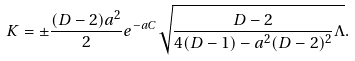Convert formula to latex. <formula><loc_0><loc_0><loc_500><loc_500>K = \pm \frac { ( D - 2 ) a ^ { 2 } } { 2 } e ^ { - a C } \sqrt { \frac { D - 2 } { 4 ( D - 1 ) - a ^ { 2 } ( D - 2 ) ^ { 2 } } \Lambda } .</formula> 